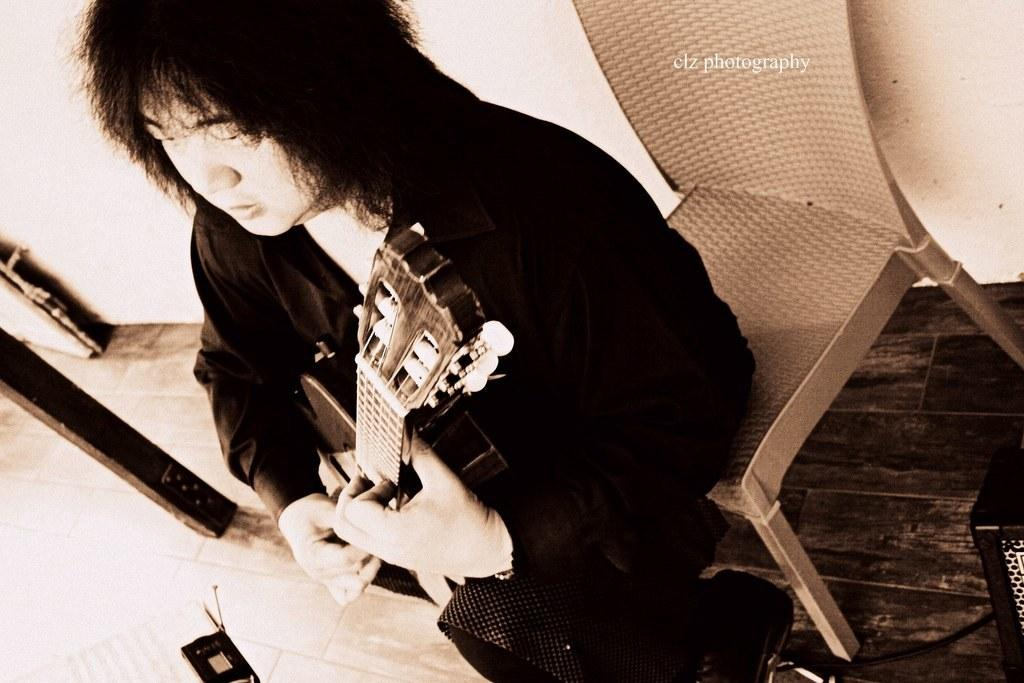Who is the main subject in the image? There is a man in the image. What is the man doing in the image? The man is sitting on a chair and playing the guitar. What is the man wearing in the image? The man is wearing a black dress. How many eggs are visible in the image? There are no eggs present in the image. What type of lock is on the gate in the image? There is no gate or lock present in the image. 